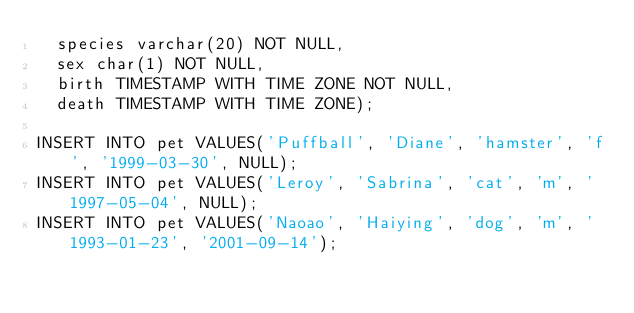<code> <loc_0><loc_0><loc_500><loc_500><_SQL_>	species varchar(20) NOT NULL,
	sex char(1) NOT NULL,
	birth TIMESTAMP WITH TIME ZONE NOT NULL,
	death TIMESTAMP WITH TIME ZONE);
 
INSERT INTO pet VALUES('Puffball', 'Diane', 'hamster', 'f', '1999-03-30', NULL);
INSERT INTO pet VALUES('Leroy', 'Sabrina', 'cat', 'm', '1997-05-04', NULL);
INSERT INTO pet VALUES('Naoao', 'Haiying', 'dog', 'm', '1993-01-23', '2001-09-14');
</code> 